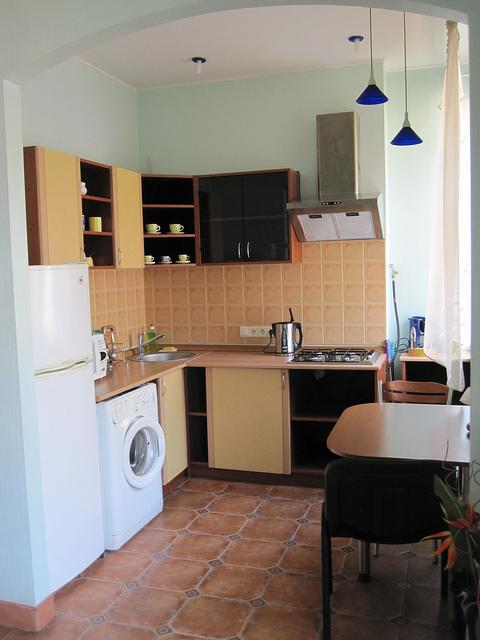Which appliance sits right next to the refrigerator? Please explain your reasoning. washing machine. Though not normal in the states, in europe it is normal for the washer to be in the kitchen. 